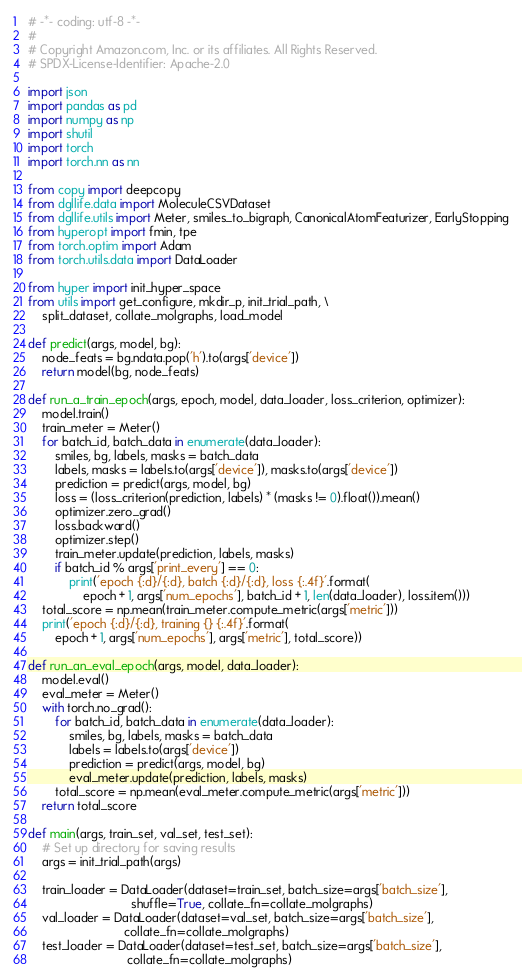Convert code to text. <code><loc_0><loc_0><loc_500><loc_500><_Python_># -*- coding: utf-8 -*-
#
# Copyright Amazon.com, Inc. or its affiliates. All Rights Reserved.
# SPDX-License-Identifier: Apache-2.0

import json
import pandas as pd
import numpy as np
import shutil
import torch
import torch.nn as nn

from copy import deepcopy
from dgllife.data import MoleculeCSVDataset
from dgllife.utils import Meter, smiles_to_bigraph, CanonicalAtomFeaturizer, EarlyStopping
from hyperopt import fmin, tpe
from torch.optim import Adam
from torch.utils.data import DataLoader

from hyper import init_hyper_space
from utils import get_configure, mkdir_p, init_trial_path, \
    split_dataset, collate_molgraphs, load_model

def predict(args, model, bg):
    node_feats = bg.ndata.pop('h').to(args['device'])
    return model(bg, node_feats)

def run_a_train_epoch(args, epoch, model, data_loader, loss_criterion, optimizer):
    model.train()
    train_meter = Meter()
    for batch_id, batch_data in enumerate(data_loader):
        smiles, bg, labels, masks = batch_data
        labels, masks = labels.to(args['device']), masks.to(args['device'])
        prediction = predict(args, model, bg)
        loss = (loss_criterion(prediction, labels) * (masks != 0).float()).mean()
        optimizer.zero_grad()
        loss.backward()
        optimizer.step()
        train_meter.update(prediction, labels, masks)
        if batch_id % args['print_every'] == 0:
            print('epoch {:d}/{:d}, batch {:d}/{:d}, loss {:.4f}'.format(
                epoch + 1, args['num_epochs'], batch_id + 1, len(data_loader), loss.item()))
    total_score = np.mean(train_meter.compute_metric(args['metric']))
    print('epoch {:d}/{:d}, training {} {:.4f}'.format(
        epoch + 1, args['num_epochs'], args['metric'], total_score))

def run_an_eval_epoch(args, model, data_loader):
    model.eval()
    eval_meter = Meter()
    with torch.no_grad():
        for batch_id, batch_data in enumerate(data_loader):
            smiles, bg, labels, masks = batch_data
            labels = labels.to(args['device'])
            prediction = predict(args, model, bg)
            eval_meter.update(prediction, labels, masks)
        total_score = np.mean(eval_meter.compute_metric(args['metric']))
    return total_score

def main(args, train_set, val_set, test_set):
    # Set up directory for saving results
    args = init_trial_path(args)

    train_loader = DataLoader(dataset=train_set, batch_size=args['batch_size'],
                              shuffle=True, collate_fn=collate_molgraphs)
    val_loader = DataLoader(dataset=val_set, batch_size=args['batch_size'],
                            collate_fn=collate_molgraphs)
    test_loader = DataLoader(dataset=test_set, batch_size=args['batch_size'],
                             collate_fn=collate_molgraphs)</code> 